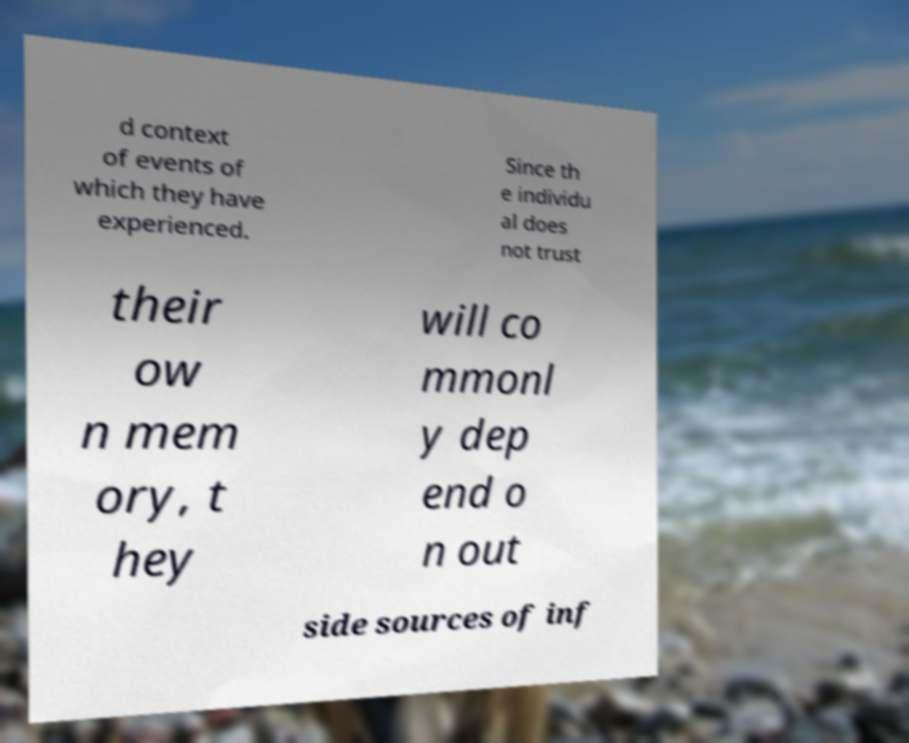Please read and relay the text visible in this image. What does it say? d context of events of which they have experienced. Since th e individu al does not trust their ow n mem ory, t hey will co mmonl y dep end o n out side sources of inf 